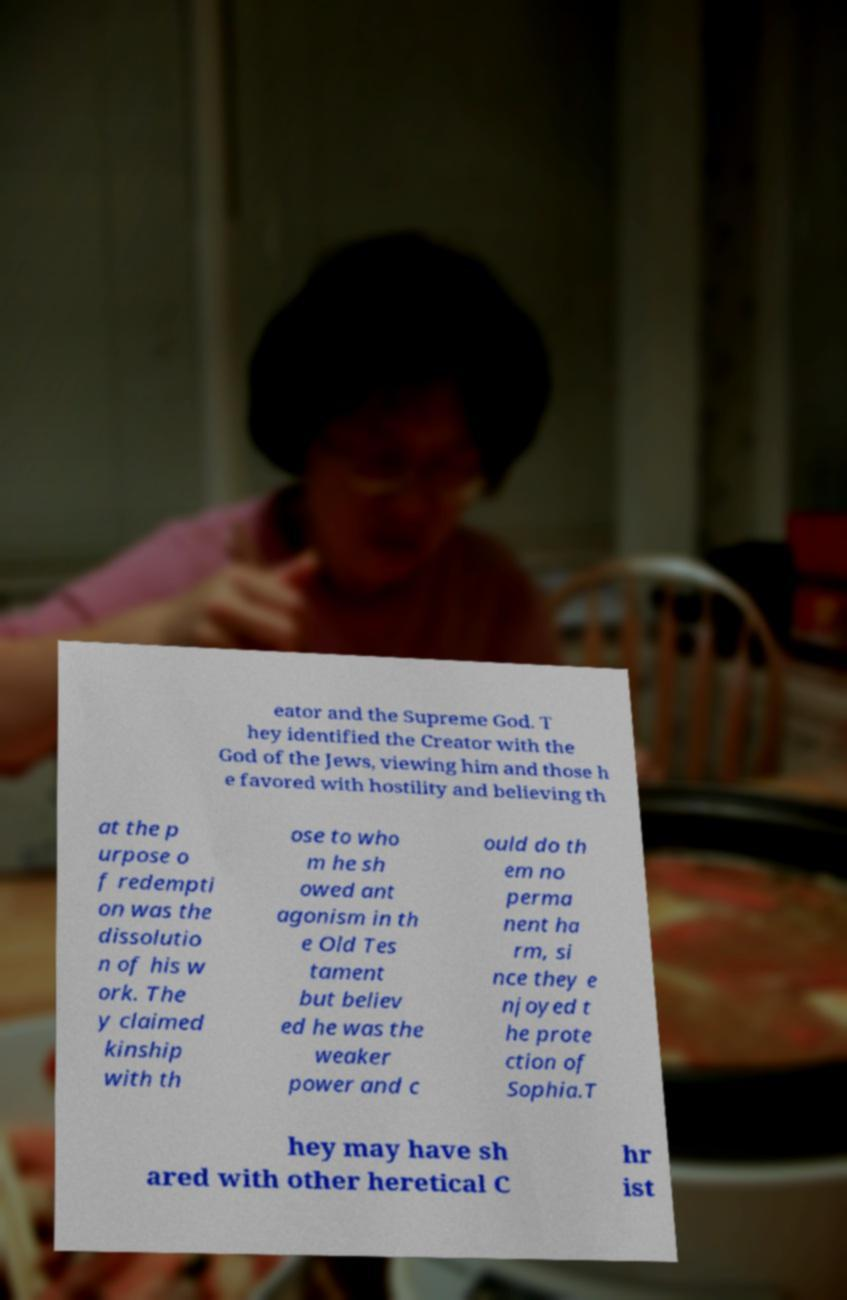Could you extract and type out the text from this image? eator and the Supreme God. T hey identified the Creator with the God of the Jews, viewing him and those h e favored with hostility and believing th at the p urpose o f redempti on was the dissolutio n of his w ork. The y claimed kinship with th ose to who m he sh owed ant agonism in th e Old Tes tament but believ ed he was the weaker power and c ould do th em no perma nent ha rm, si nce they e njoyed t he prote ction of Sophia.T hey may have sh ared with other heretical C hr ist 